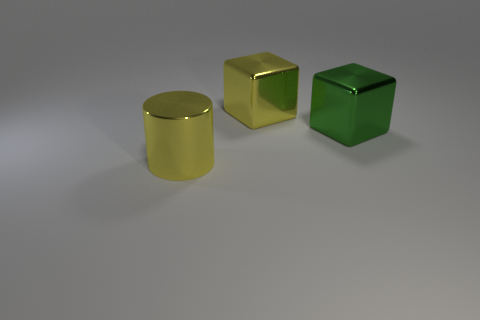Add 1 yellow metallic things. How many objects exist? 4 Subtract all cylinders. How many objects are left? 2 Subtract all big yellow cylinders. Subtract all big shiny cubes. How many objects are left? 0 Add 2 metal blocks. How many metal blocks are left? 4 Add 2 yellow shiny cubes. How many yellow shiny cubes exist? 3 Subtract 1 yellow cylinders. How many objects are left? 2 